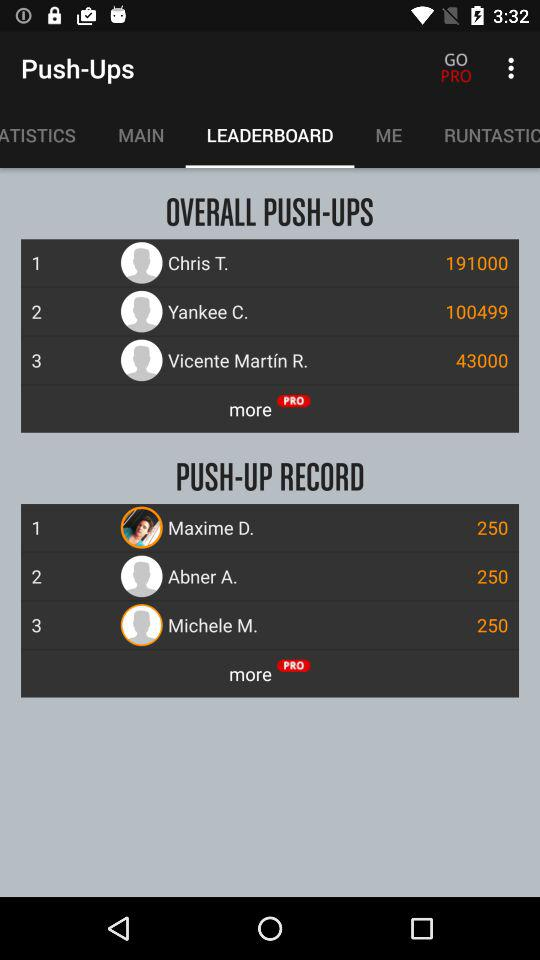How many overall push-ups did Yankee C. do? The overall number of push-ups Yankee C. did is 100,499. 